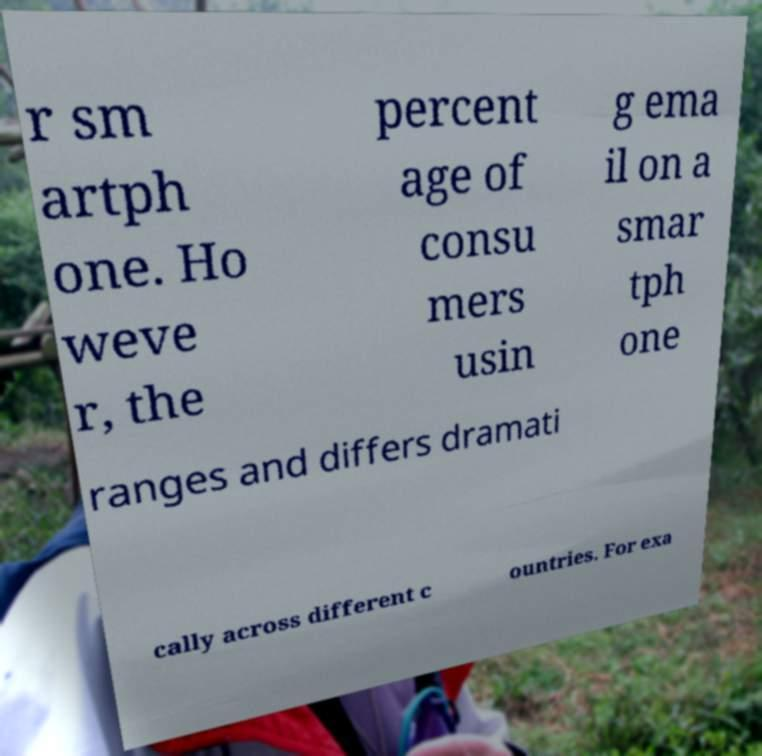What messages or text are displayed in this image? I need them in a readable, typed format. r sm artph one. Ho weve r, the percent age of consu mers usin g ema il on a smar tph one ranges and differs dramati cally across different c ountries. For exa 